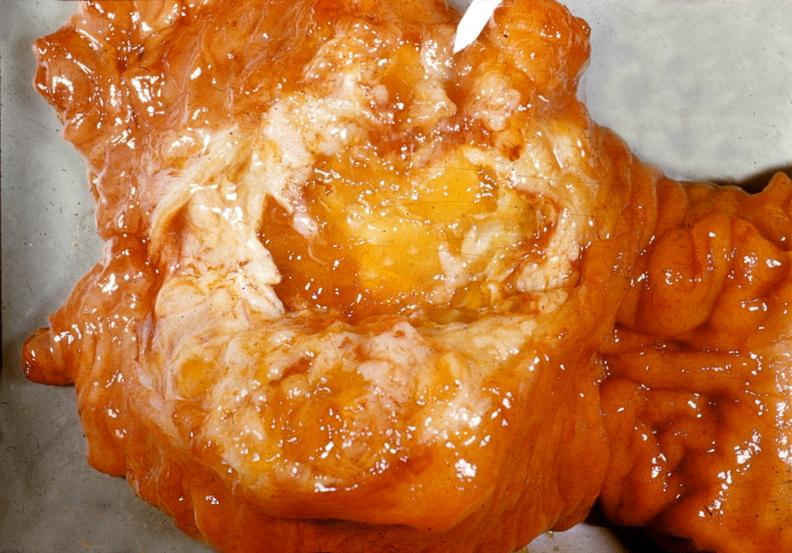s pancreas present?
Answer the question using a single word or phrase. Yes 